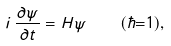<formula> <loc_0><loc_0><loc_500><loc_500>i \, \frac { \partial \psi } { \partial t } = H \psi \quad ( \hbar { = } 1 ) ,</formula> 